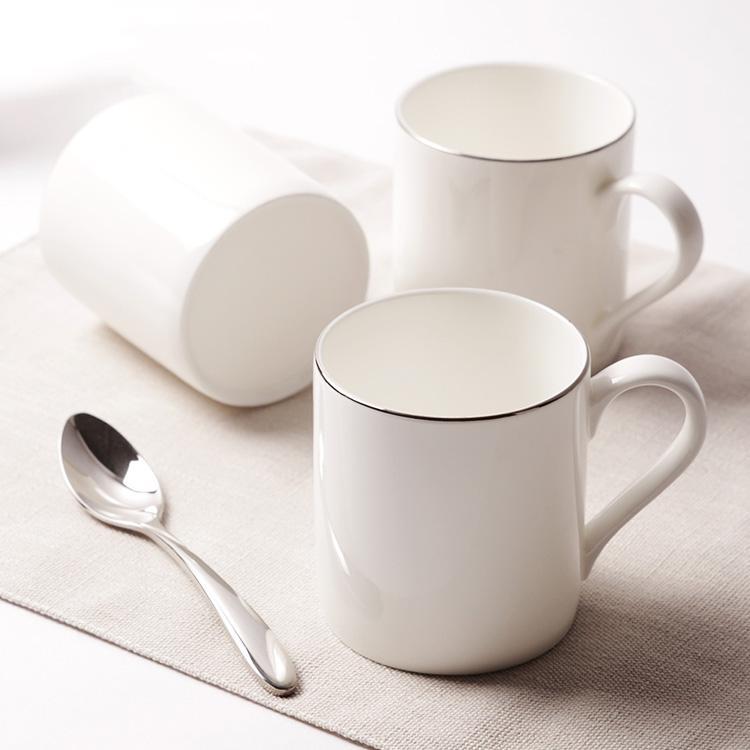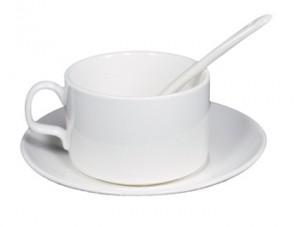The first image is the image on the left, the second image is the image on the right. Analyze the images presented: Is the assertion "There are three or more tea cups." valid? Answer yes or no. Yes. The first image is the image on the left, the second image is the image on the right. Considering the images on both sides, is "A spoon is resting on a saucer near a tea cup." valid? Answer yes or no. No. 